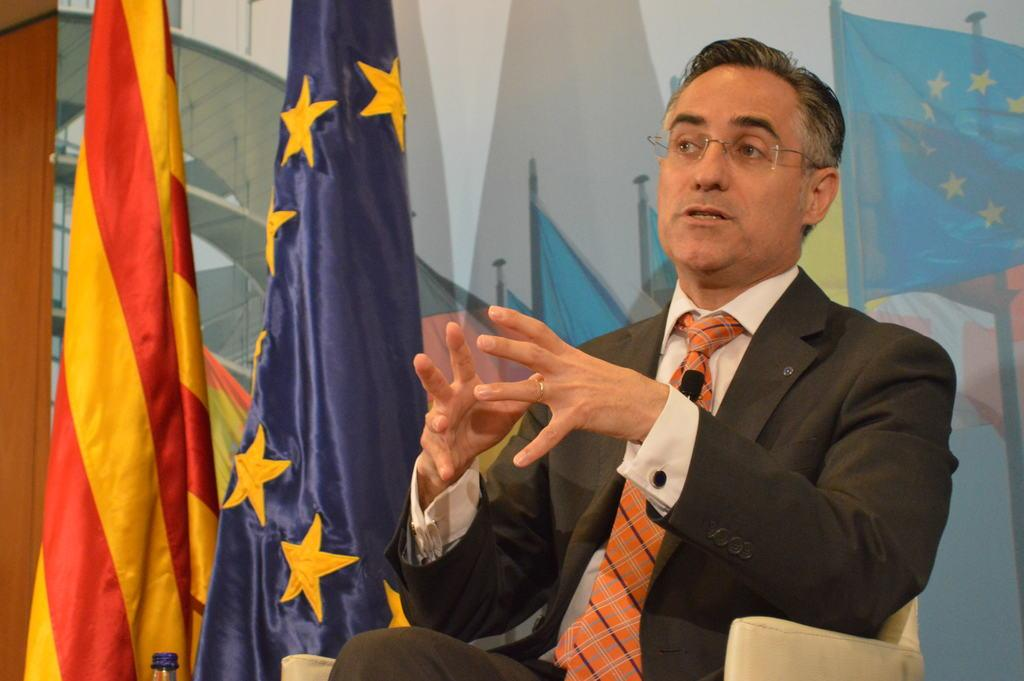What is the person in the image doing? The person is sitting on a chair and talking. What can be seen beside the person? There are two flags beside the person. What is present on the wall in the image? There is a painting on the wall. What is the background of the image? There is a wall in the image. What type of wealth is depicted in the painting on the wall? There is no indication of wealth in the painting on the wall, as the image does not provide any information about the content of the painting. 